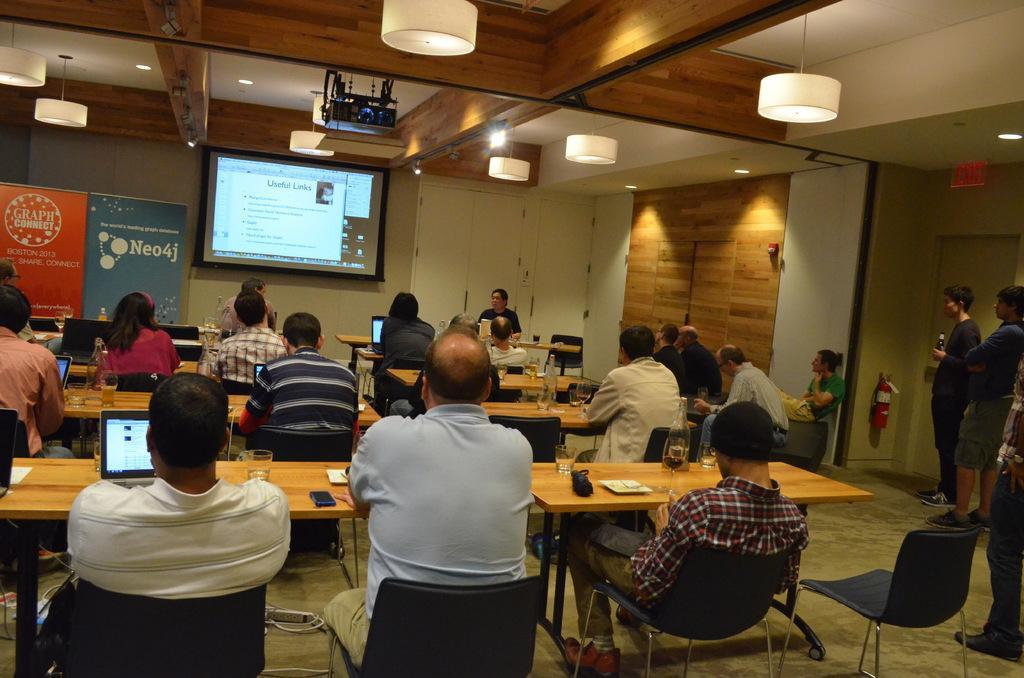How would you summarize this image in a sentence or two? in a room there are tables and chairs and people are sitting on the chairs. on the tables there are laptops, glasses. at the left people are standing. at the back there's a wall and a projector display. at the right back there are blue and red banners. at the top there are lights. a the left there is a wooden door. 